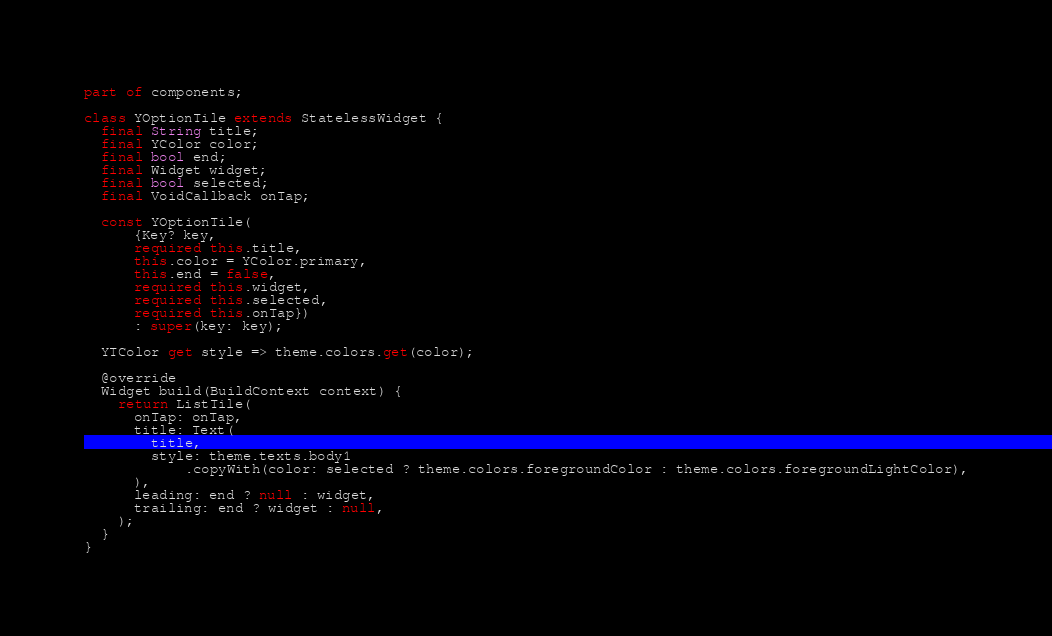<code> <loc_0><loc_0><loc_500><loc_500><_Dart_>part of components;

class YOptionTile extends StatelessWidget {
  final String title;
  final YColor color;
  final bool end;
  final Widget widget;
  final bool selected;
  final VoidCallback onTap;

  const YOptionTile(
      {Key? key,
      required this.title,
      this.color = YColor.primary,
      this.end = false,
      required this.widget,
      required this.selected,
      required this.onTap})
      : super(key: key);

  YTColor get style => theme.colors.get(color);

  @override
  Widget build(BuildContext context) {
    return ListTile(
      onTap: onTap,
      title: Text(
        title,
        style: theme.texts.body1
            .copyWith(color: selected ? theme.colors.foregroundColor : theme.colors.foregroundLightColor),
      ),
      leading: end ? null : widget,
      trailing: end ? widget : null,
    );
  }
}
</code> 